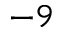Convert formula to latex. <formula><loc_0><loc_0><loc_500><loc_500>^ { - 9 }</formula> 